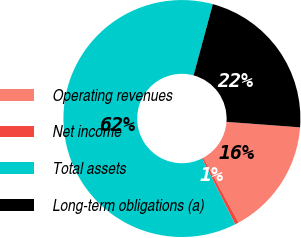Convert chart. <chart><loc_0><loc_0><loc_500><loc_500><pie_chart><fcel>Operating revenues<fcel>Net income<fcel>Total assets<fcel>Long-term obligations (a)<nl><fcel>15.87%<fcel>0.52%<fcel>61.62%<fcel>21.98%<nl></chart> 